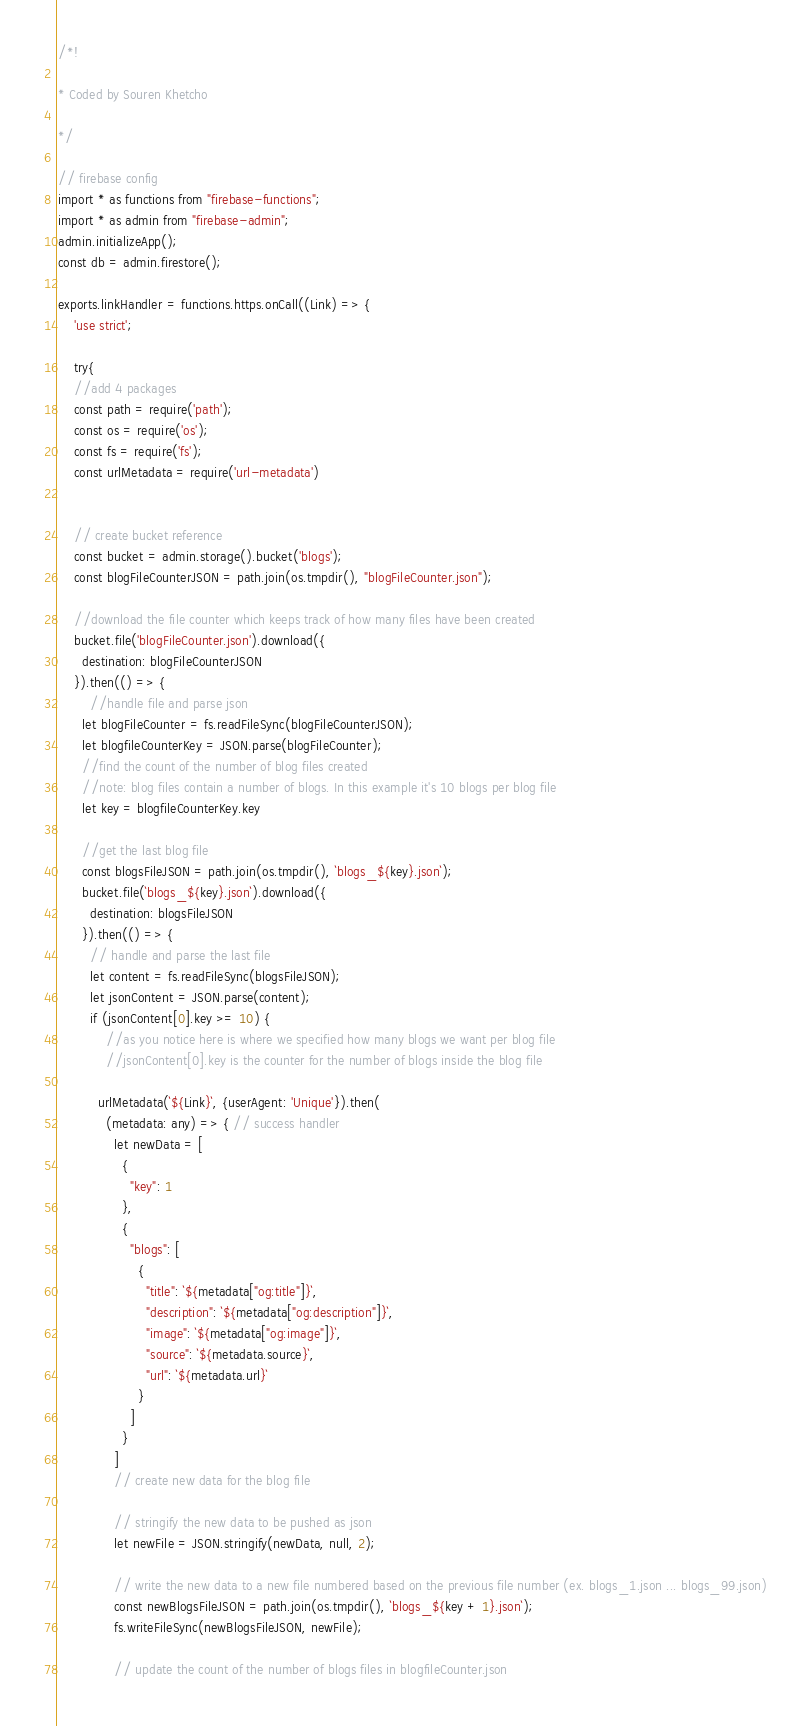Convert code to text. <code><loc_0><loc_0><loc_500><loc_500><_TypeScript_>/*!

* Coded by Souren Khetcho

*/

// firebase config
import * as functions from "firebase-functions";
import * as admin from "firebase-admin";
admin.initializeApp();
const db = admin.firestore();

exports.linkHandler = functions.https.onCall((Link) => {
    'use strict';
  
    try{
    //add 4 packages
    const path = require('path');
    const os = require('os');
    const fs = require('fs');
    const urlMetadata = require('url-metadata')
  
  
    // create bucket reference
    const bucket = admin.storage().bucket('blogs');
    const blogFileCounterJSON = path.join(os.tmpdir(), "blogFileCounter.json");

    //download the file counter which keeps track of how many files have been created
    bucket.file('blogFileCounter.json').download({
      destination: blogFileCounterJSON
    }).then(() => {
        //handle file and parse json
      let blogFileCounter = fs.readFileSync(blogFileCounterJSON);
      let blogfileCounterKey = JSON.parse(blogFileCounter);
      //find the count of the number of blog files created
      //note: blog files contain a number of blogs. In this example it's 10 blogs per blog file
      let key = blogfileCounterKey.key
        
      //get the last blog file
      const blogsFileJSON = path.join(os.tmpdir(), `blogs_${key}.json`);
      bucket.file(`blogs_${key}.json`).download({
        destination: blogsFileJSON
      }).then(() => {
        // handle and parse the last file
        let content = fs.readFileSync(blogsFileJSON);
        let jsonContent = JSON.parse(content);
        if (jsonContent[0].key >= 10) {
            //as you notice here is where we specified how many blogs we want per blog file
            //jsonContent[0].key is the counter for the number of blogs inside the blog file
  
          urlMetadata(`${Link}`, {userAgent: 'Unique'}).then(
            (metadata: any) => { // success handler
              let newData = [
                {
                  "key": 1
                },
                {
                  "blogs": [
                    {
                      "title": `${metadata["og:title"]}`,
                      "description": `${metadata["og:description"]}`,
                      "image": `${metadata["og:image"]}`,
                      "source": `${metadata.source}`,
                      "url": `${metadata.url}`
                    }
                  ]
                }
              ]
              // create new data for the blog file
  
              // stringify the new data to be pushed as json
              let newFile = JSON.stringify(newData, null, 2);
  
              // write the new data to a new file numbered based on the previous file number (ex. blogs_1.json ... blogs_99.json)
              const newBlogsFileJSON = path.join(os.tmpdir(), `blogs_${key + 1}.json`);
              fs.writeFileSync(newBlogsFileJSON, newFile);
  
              // update the count of the number of blogs files in blogfileCounter.json</code> 